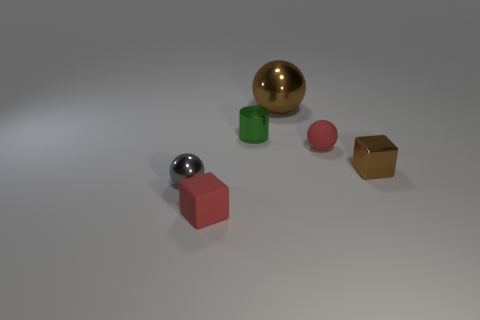What lighting conditions are present in the image? The lighting in the image is soft and diffused, coming from a direction that casts very soft shadows to the right of the objects. This suggests an indoor setting with possibly overhead lighting, which is not too harsh, creating a calm and neutral environment. 